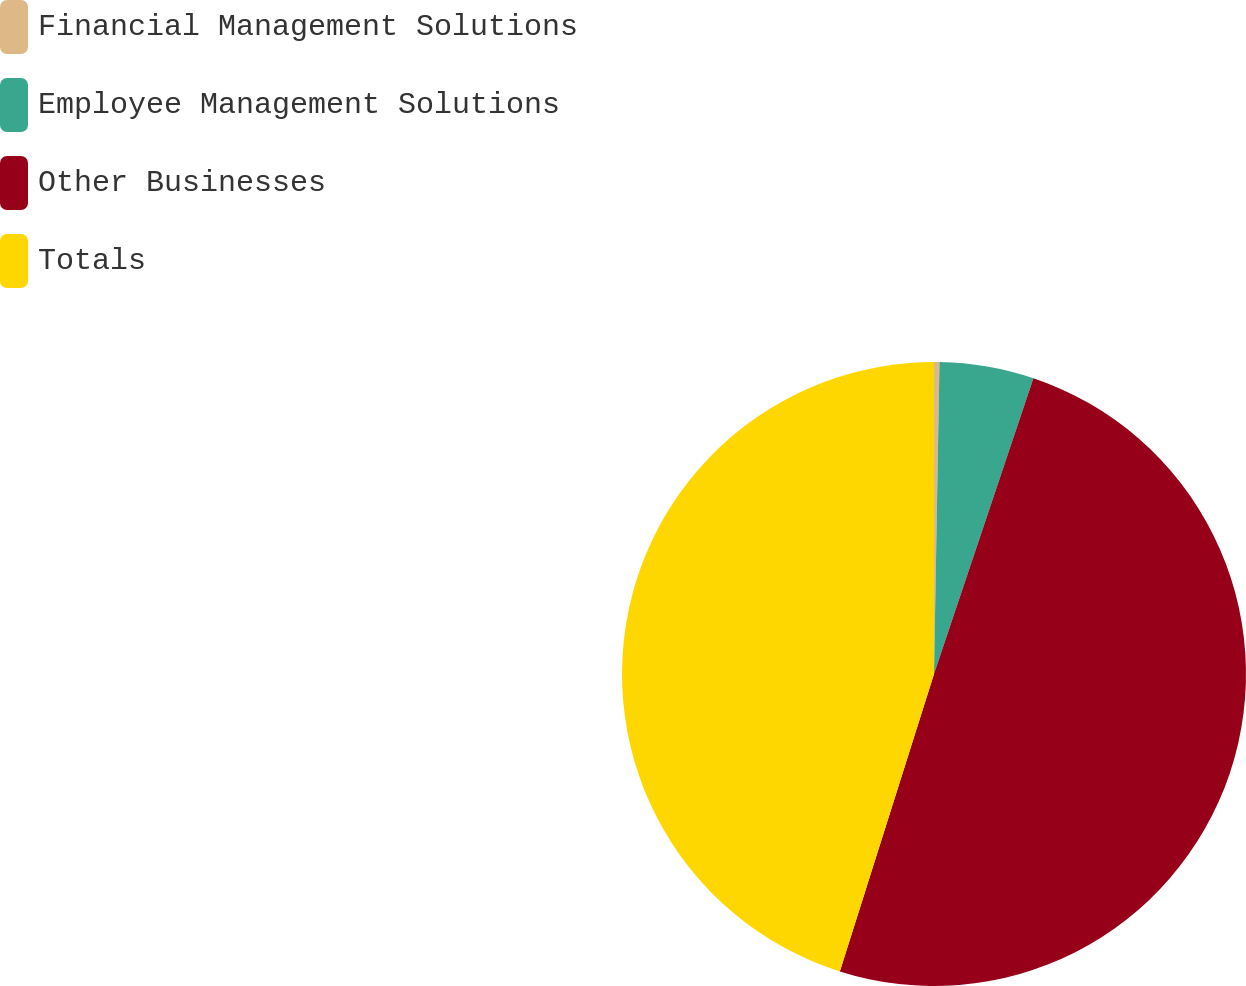<chart> <loc_0><loc_0><loc_500><loc_500><pie_chart><fcel>Financial Management Solutions<fcel>Employee Management Solutions<fcel>Other Businesses<fcel>Totals<nl><fcel>0.28%<fcel>4.88%<fcel>49.72%<fcel>45.12%<nl></chart> 